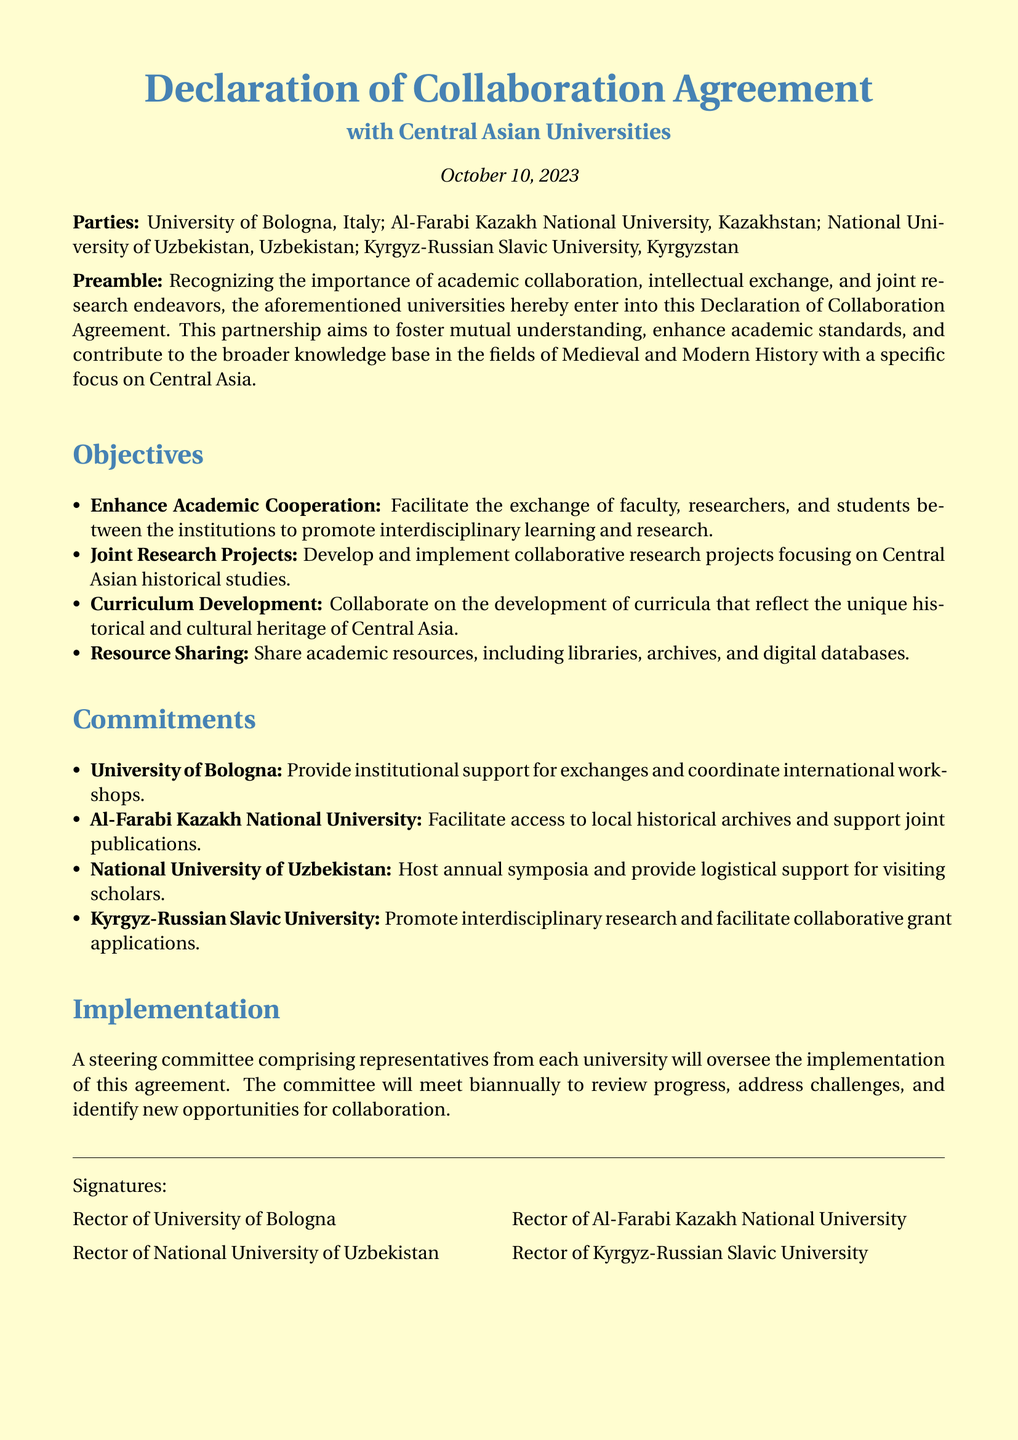What is the date of the declaration? The date of the declaration is stated at the beginning of the document.
Answer: October 10, 2023 Who are the partnering universities listed in the declaration? The declaration lists four universities as partners.
Answer: University of Bologna, Al-Farabi Kazakh National University, National University of Uzbekistan, Kyrgyz-Russian Slavic University What is one of the objectives of the collaboration? The document outlines several objectives, specifically mentioning cooperation and research.
Answer: Enhance Academic Cooperation How often will the steering committee meet? The document specifies the meeting frequency of the committee overseeing the implementation.
Answer: Biannually What is the commitment of the National University of Uzbekistan? Each university has stated specific commitments in the document.
Answer: Host annual symposia What is the focus of the joint research projects mentioned? The document highlights the subject of the collaborative research projects the universities plan to work on.
Answer: Central Asian historical studies What type of support will University of Bologna provide? The commitments section details what University of Bologna will do as part of the agreement.
Answer: Provide institutional support for exchanges Which university will facilitate access to local historical archives? The commitments outline responsibilities assigned to each university.
Answer: Al-Farabi Kazakh National University What color theme is used in the document? The document uses specific colors that are defined in the code.
Answer: Medieval blue and parchment 